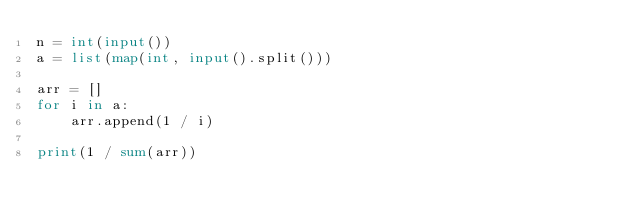<code> <loc_0><loc_0><loc_500><loc_500><_Python_>n = int(input())
a = list(map(int, input().split()))

arr = []
for i in a:
    arr.append(1 / i)

print(1 / sum(arr))
</code> 